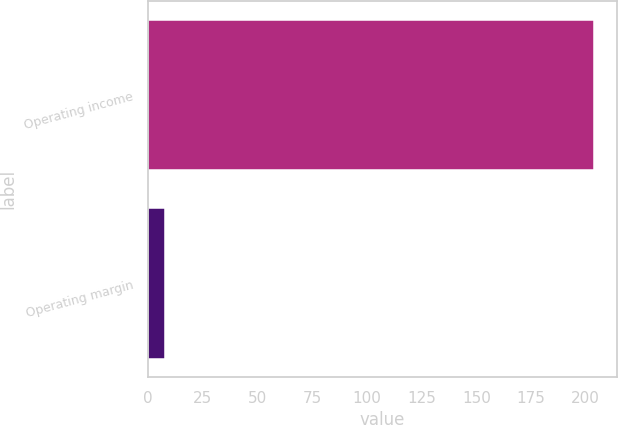<chart> <loc_0><loc_0><loc_500><loc_500><bar_chart><fcel>Operating income<fcel>Operating margin<nl><fcel>204<fcel>7.5<nl></chart> 